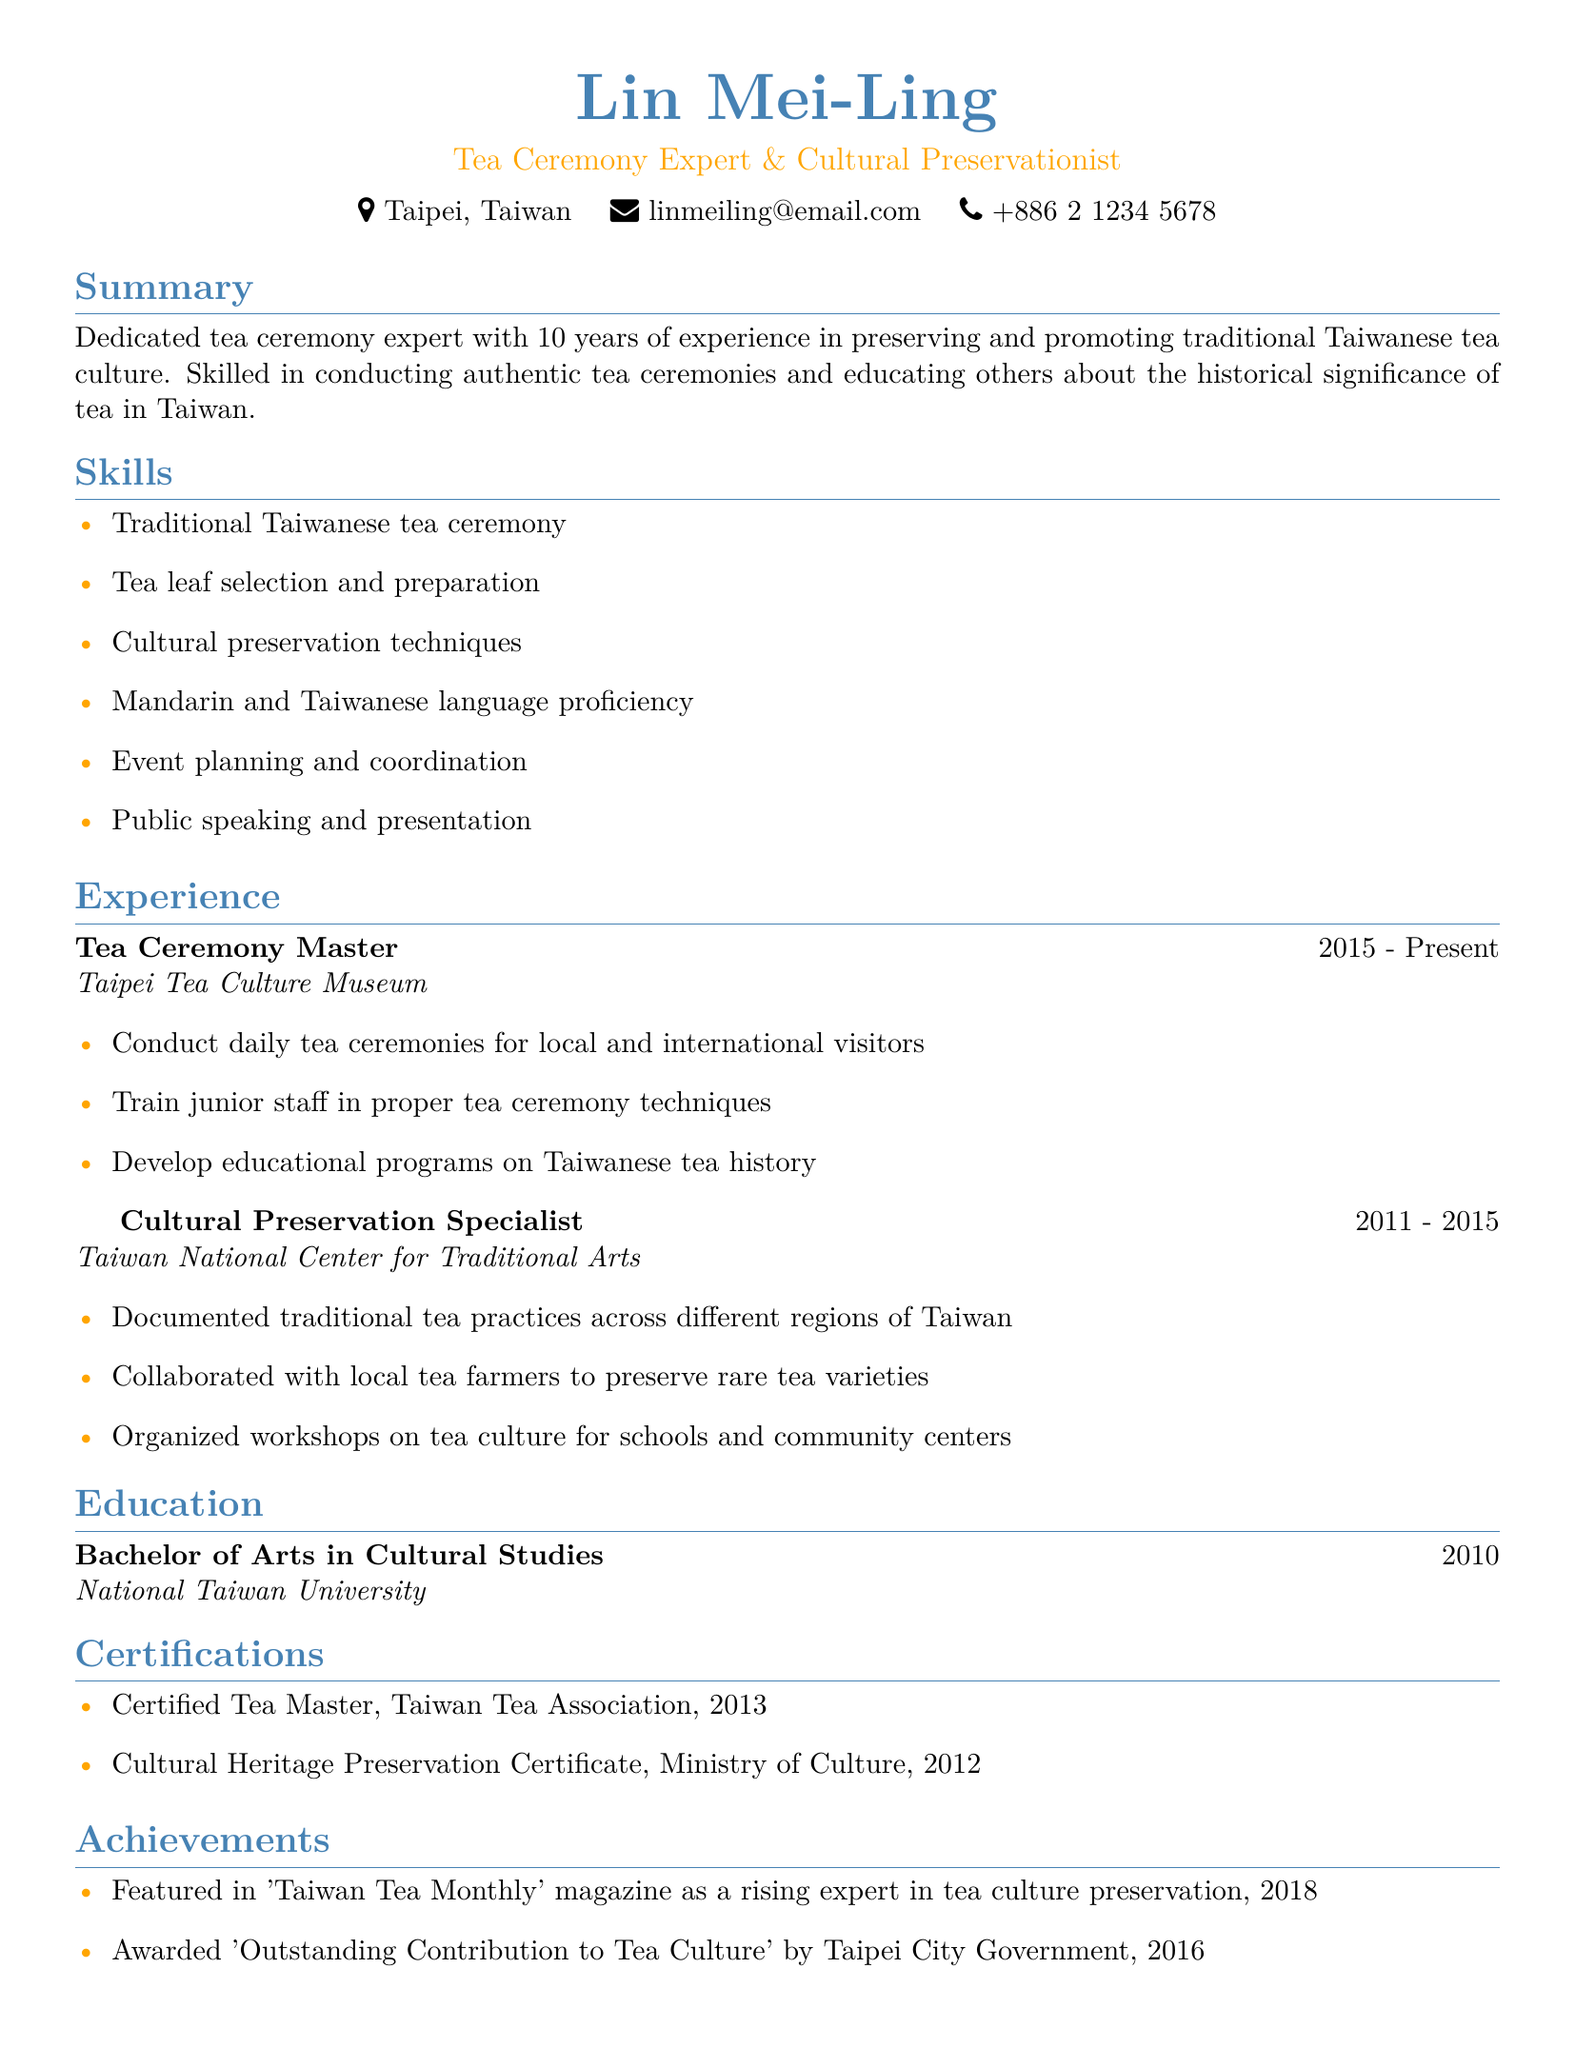What is Lin Mei-Ling's position? The document clearly states her title as "Tea Ceremony Expert & Cultural Preservationist."
Answer: Tea Ceremony Expert & Cultural Preservationist What year did Lin Mei-Ling start her current role? According to the document, she has been working as a Tea Ceremony Master since 2015.
Answer: 2015 Which organization did Lin Mei-Ling work for before the Taipei Tea Culture Museum? The resume lists the preceding organization as the "Taiwan National Center for Traditional Arts."
Answer: Taiwan National Center for Traditional Arts What degree does Lin Mei-Ling hold? The document specifies her degree as "Bachelor of Arts in Cultural Studies."
Answer: Bachelor of Arts in Cultural Studies How many years of experience does Lin Mei-Ling have in tea culture? The summary mentions she has 10 years of experience.
Answer: 10 years What is one skill listed under Lin Mei-Ling's skills? The document clearly states multiple skills; one of them is "Tea leaf selection and preparation."
Answer: Tea leaf selection and preparation Which award did Lin Mei-Ling receive in 2016? The achievements section states she was awarded "Outstanding Contribution to Tea Culture" by Taipei City Government in 2016.
Answer: Outstanding Contribution to Tea Culture In what year was Lin Mei-Ling featured in 'Taiwan Tea Monthly'? The achievements section indicates she was featured in 2018.
Answer: 2018 How many certifications does Lin Mei-Ling have listed? The document mentions two certifications she has obtained.
Answer: Two 